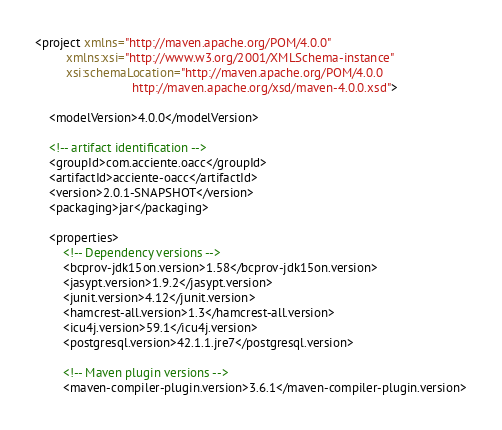<code> <loc_0><loc_0><loc_500><loc_500><_XML_><project xmlns="http://maven.apache.org/POM/4.0.0"
         xmlns:xsi="http://www.w3.org/2001/XMLSchema-instance"
         xsi:schemaLocation="http://maven.apache.org/POM/4.0.0
                            http://maven.apache.org/xsd/maven-4.0.0.xsd">

    <modelVersion>4.0.0</modelVersion>

    <!-- artifact identification -->
    <groupId>com.acciente.oacc</groupId>
    <artifactId>acciente-oacc</artifactId>
    <version>2.0.1-SNAPSHOT</version>
    <packaging>jar</packaging>

    <properties>
        <!-- Dependency versions -->
        <bcprov-jdk15on.version>1.58</bcprov-jdk15on.version>
        <jasypt.version>1.9.2</jasypt.version>
        <junit.version>4.12</junit.version>
        <hamcrest-all.version>1.3</hamcrest-all.version>
        <icu4j.version>59.1</icu4j.version>
        <postgresql.version>42.1.1.jre7</postgresql.version>

        <!-- Maven plugin versions -->
        <maven-compiler-plugin.version>3.6.1</maven-compiler-plugin.version></code> 